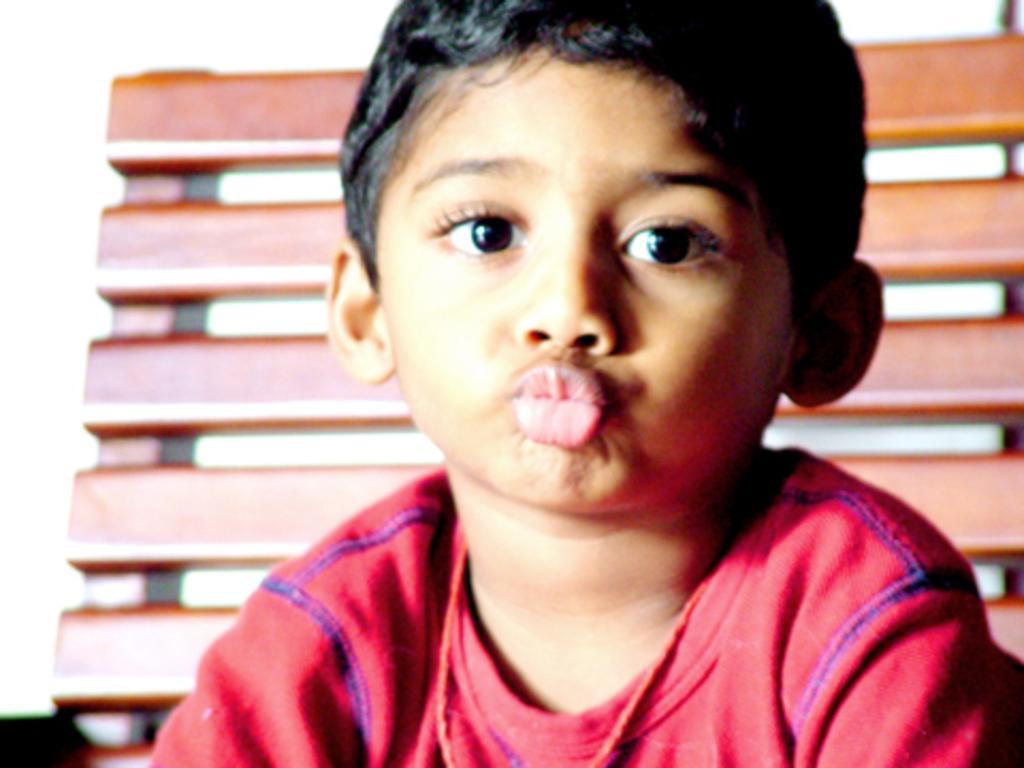In one or two sentences, can you explain what this image depicts? In this image I can see a boy is there, he wore red color t-shirt. Behind him it may be wooden frame. 